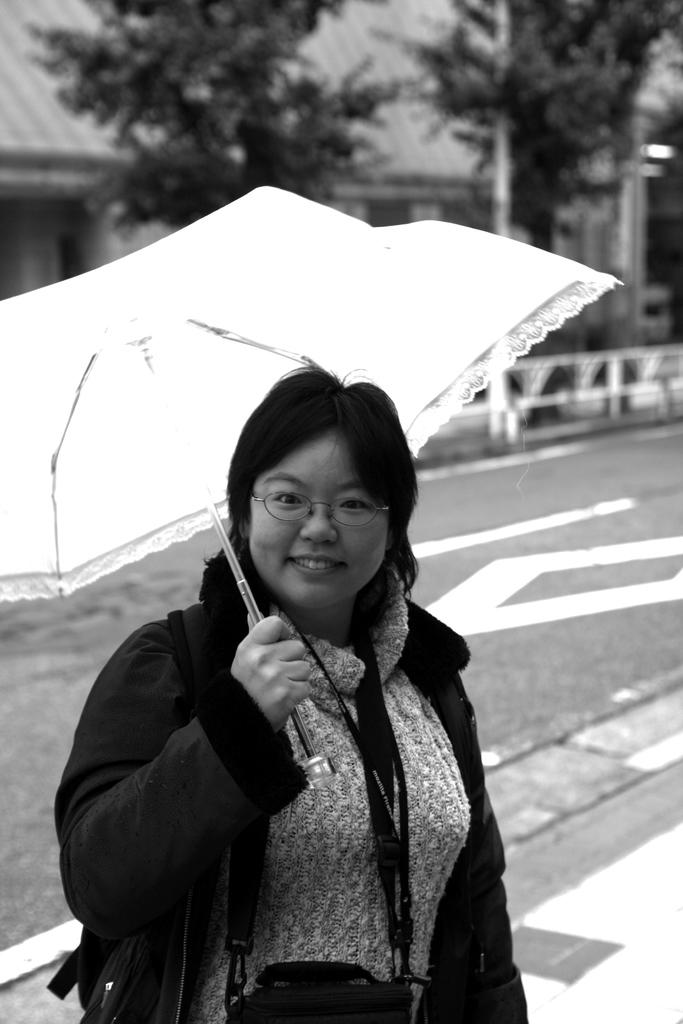What is the person in the image doing? The person is standing in the image. What object is the person holding? The person is holding an umbrella. What can be seen in the background of the image? There are trees and buildings in the background of the image. What is the color scheme of the image? The image is in black and white. What type of berry is the person eating in the image? There is no berry present in the image, and the person is not eating anything. What kind of jeans is the person wearing in the image? The image is in black and white, so it is not possible to determine the color or type of jeans the person might be wearing. 